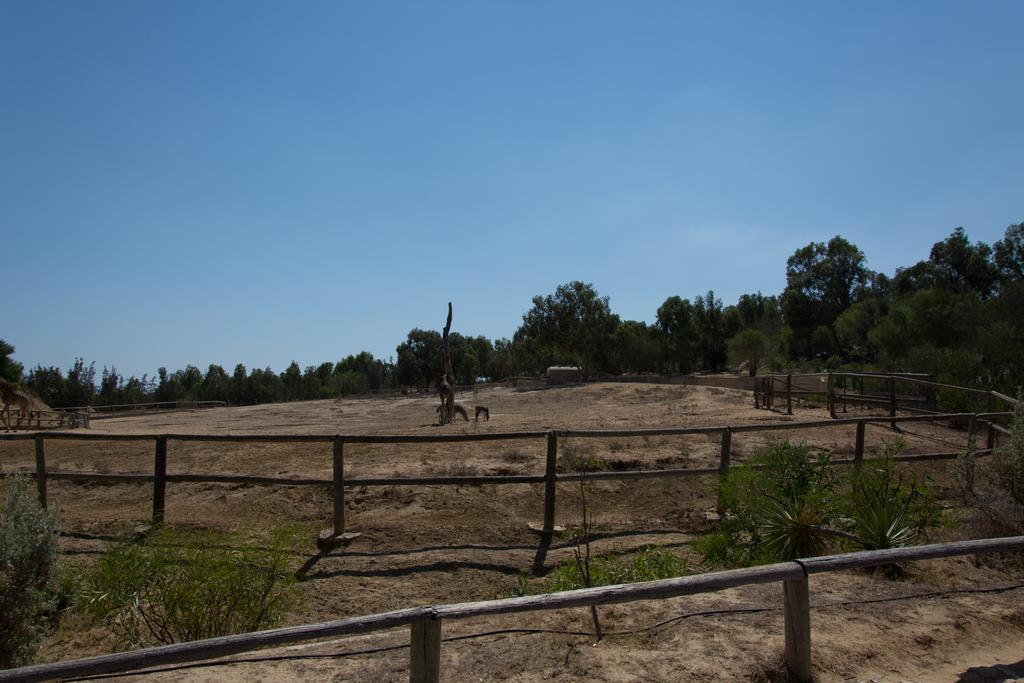What is the main feature that stretches from left to right in the image? There is a fence in the image, stretching from left to right. What type of vegetation can be seen in the image? There are a few plants in the image. What is present in the path in the image? There are some objects in the path. Where are the plants located on the right side of the image? The plants are on the right side of the image. What color is the sky in the image? The sky is blue in color. What type of representative is shown holding a baseball bat in the image? There is no representative or baseball bat present in the image. What type of scissors are used to trim the plants in the image? There are no scissors visible in the image, and the plants do not appear to be trimmed. 